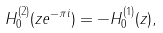Convert formula to latex. <formula><loc_0><loc_0><loc_500><loc_500>H ^ { ( 2 ) } _ { 0 } ( z e ^ { - \pi i } ) = - H ^ { ( 1 ) } _ { 0 } ( z ) ,</formula> 